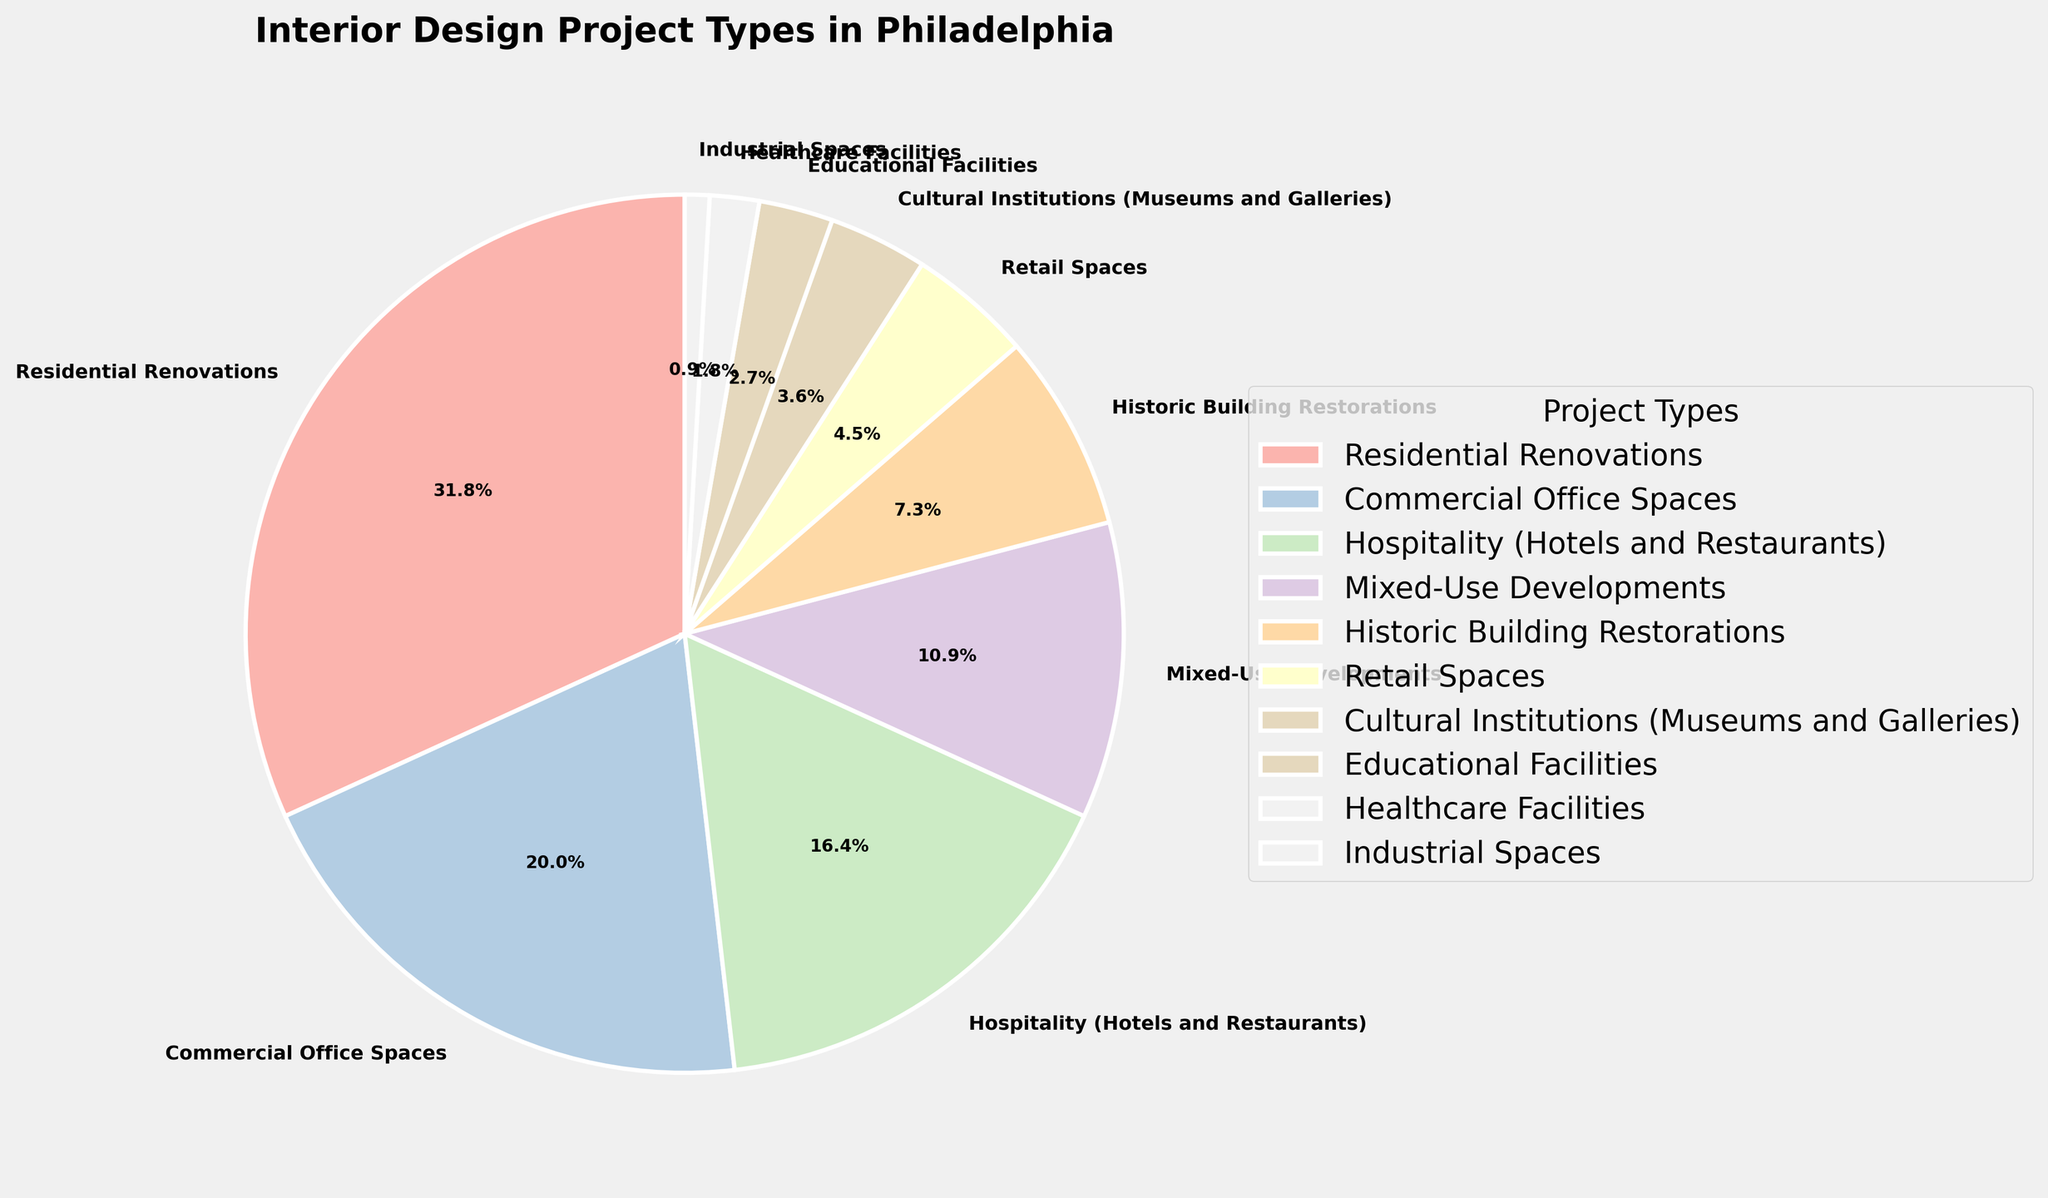What's the most common type of interior design project in Philadelphia? Looking at the pie chart, the segment with the largest percentage represents the most common project type. It's clearly visible that the largest segment is Residential Renovations.
Answer: Residential Renovations Which two project types combined make up 40% of the interior design projects? By examining the chart, we see Residential Renovations is 35% and Historic Building Restorations is 8%. Together, they exceed 40%, so it must be different. The next likely pair is Residential Renovations (35%) and Retail Spaces (5%), which together make exactly 40%.
Answer: Residential Renovations and Retail Spaces Are commercial office spaces more common than hospitality projects? By comparing the two segments, Commercial Office Spaces and Hospitality (Hotels and Restaurants), we see Commercial Office Spaces is 22%, and Hospitality is 18%. Since 22% is greater than 18%, Commercial Office Spaces are more common.
Answer: Yes How much more prevalent are residential renovations compared to mixed-use developments? Residential Renovations are 35%, and Mixed-Use Developments are 12%. The difference between them is 35% - 12% = 23%.
Answer: 23% What percentage of projects are related to historical buildings? The segment labeled Historic Building Restorations represents these projects, which is 8%.
Answer: 8% Which project type has the smallest representation, and what is its percentage? The smallest segment on the chart is labeled Industrial Spaces. Its percentage is 1%.
Answer: Industrial Spaces, 1% By what percentage does commercial office space exceed education facilities? Commercial Office Spaces constitute 22%, and Educational Facilities constitute 3%. The difference is 22% - 3% = 19%.
Answer: 19% Can you identify two project types that together form approximately a quarter of the total projects? Hospitality (18%) and Mixed-Use Developments (12%) together make up 30%, which is slightly more. The next best combination would be Mixed-Use Developments (12%) and Historic Building Restorations (8%), which equal 20% but are less. Try Hospitality (18%) and Retail Spaces (5%) which add up to 23%. This is closer.
Answer: Hospitality and Retail Spaces How does the representation of cultural institutions compare to healthcare facilities? Cultural Institutions (Museums and Galleries) make up 4%, whereas Healthcare Facilities make up 2%. Therefore, Cultural Institutions are twice as prevalent as Healthcare Facilities.
Answer: Cultural Institutions are twice as prevalent 